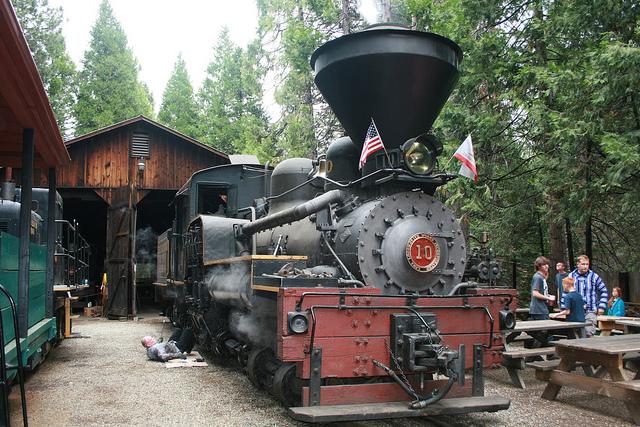How many flags are on the train?
Short answer required. 2. What number is on the train?
Answer briefly. 10. Approximately how old do you think this photograph is?
Write a very short answer. 5 years. What type of train is this?
Give a very brief answer. Steam. Is the train in motion?
Answer briefly. No. What is the engine number?
Quick response, please. 10. Is there smoke coming out of the engine?
Be succinct. Yes. 